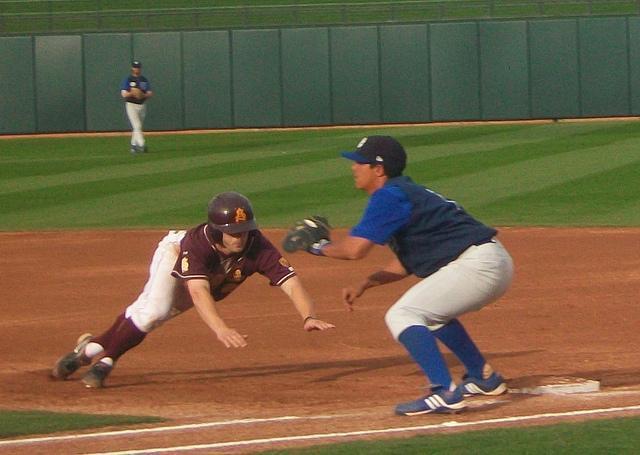What shapes are in the grass?
Indicate the correct choice and explain in the format: 'Answer: answer
Rationale: rationale.'
Options: Letters, numbers, circled, stripes. Answer: circled.
Rationale: There are stripes in the baseball field. 